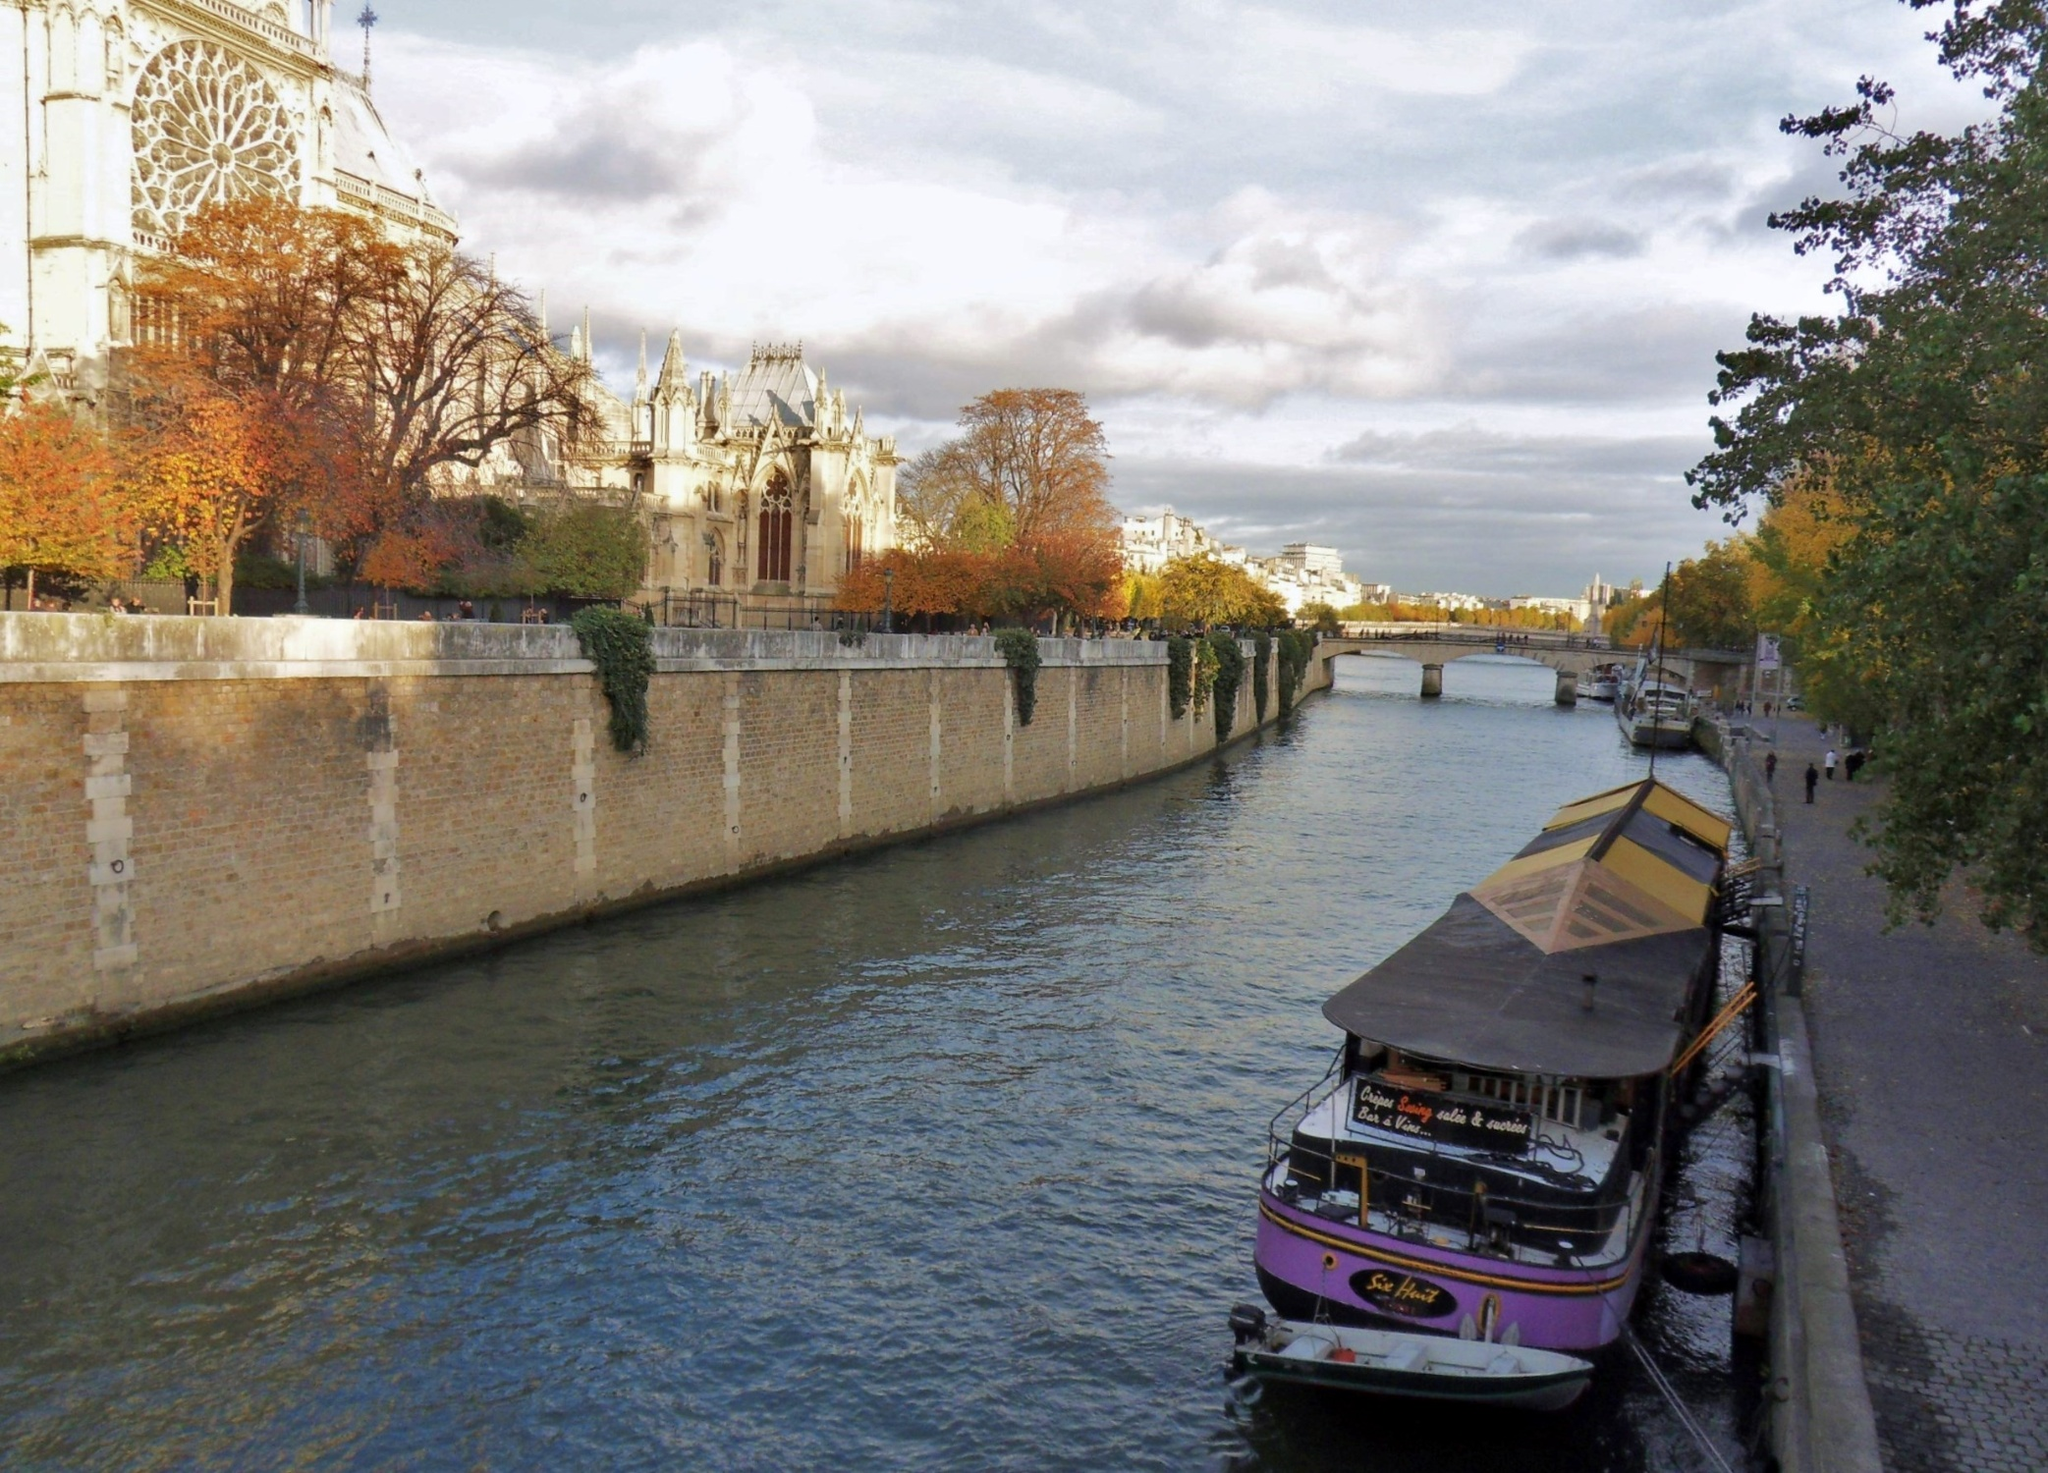What stands out the most to you in this image? The most striking element in this image is the Notre Dame Cathedral. Its architectural grandeur and iconic structure draw the eye, instantly placing the scene in Paris. The cathedral's detailed flying buttresses and tall spire add an element of historical magnificence to the serene river scene. Could you tell me more about the boat on the river? Certainly! The boat moored on the right side of the image has a unique and charming appearance, enhanced by its brown roof and a whimsical pink and white striped awning. It seems to be docked near the river's edge, possibly serving as a cozy riverside café or a leisure boat offering scenic tours along the Seine. The name 'La Péniche' inscribed on the boat suggests it might be a traditional barge, a common sight on Parisian waterways, adding to the authenticity and charm of the scene. Imagine if this scene were part of a painting from the 1800s. How would you describe it? Imagine this scene as an exquisite painting, crafted with the finesse and style reminiscent of the 1800s. The Seine River, with its gentle flow, forms the central artery of the Parisian landscape. On the right bank, a rustic wooden boat moored with a quaint awning hints at a simpler, slower pace of life. The stone embankment to the left rises majestically, with trees displaying an enchanting array of autumn colors – vivid oranges, deep reds, and golden hues blending into the serene backdrop. Dominating the skyline is the iconic Notre Dame Cathedral, captured in meticulous detail with its soaring spire and intricately designed flying buttresses, embodying an era of architectural splendor. The sky, vast and open, dotted with fluffy clouds, reflects the tranquility of a perfect autumn day in Paris. This painting, with its rich colors and historical depth, would capture the serene essence and timeless beauty of 19th-century Paris. 